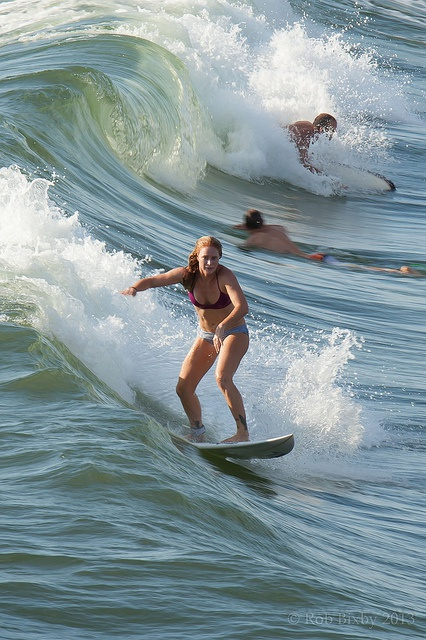Describe the objects in this image and their specific colors. I can see people in darkgray, gray, brown, maroon, and black tones, people in darkgray, gray, black, and maroon tones, surfboard in darkgray, black, and gray tones, people in darkgray, gray, and black tones, and surfboard in darkgray and gray tones in this image. 